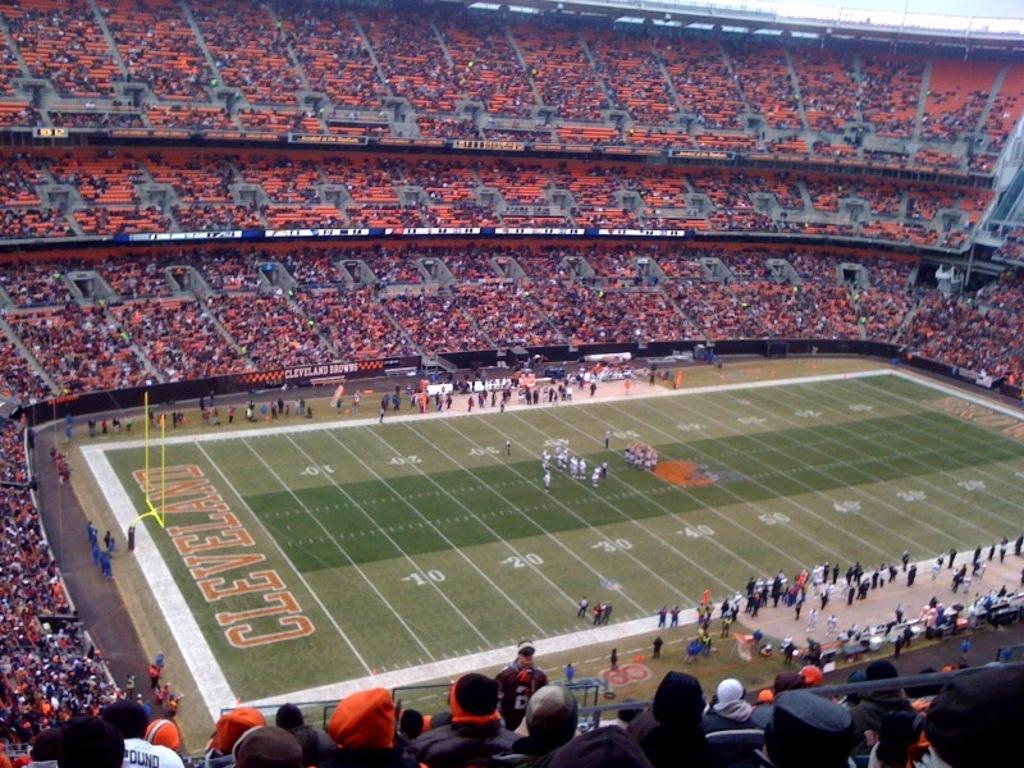<image>
Share a concise interpretation of the image provided. the football feild is getting ready for the Cleveland game. 